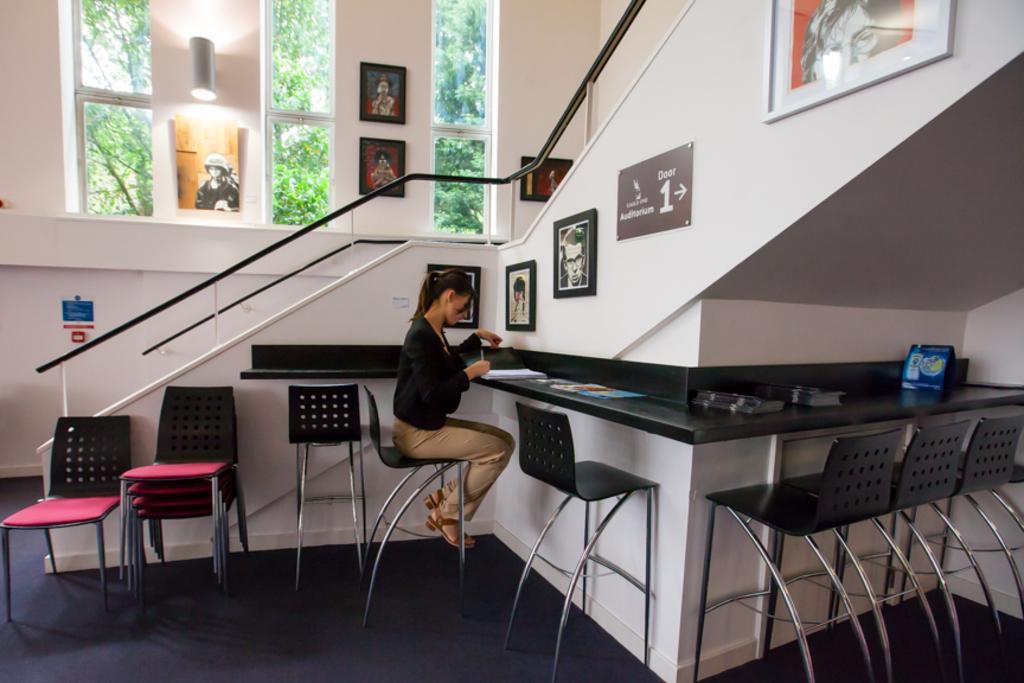How would you summarize this image in a sentence or two? In this image there is a person sitting on a chair, at the left side of the person there is a staircase and there are many chairs and at the back there is a window, there are photo frames on the wall. At the outside there is a tree. 